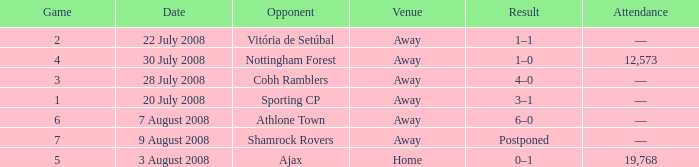What is the result of the game with a game number greater than 6 and an away venue? Postponed. 